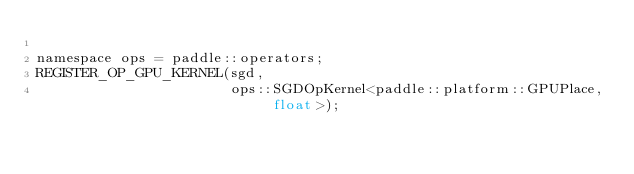<code> <loc_0><loc_0><loc_500><loc_500><_Cuda_>
namespace ops = paddle::operators;
REGISTER_OP_GPU_KERNEL(sgd,
                       ops::SGDOpKernel<paddle::platform::GPUPlace, float>);
</code> 